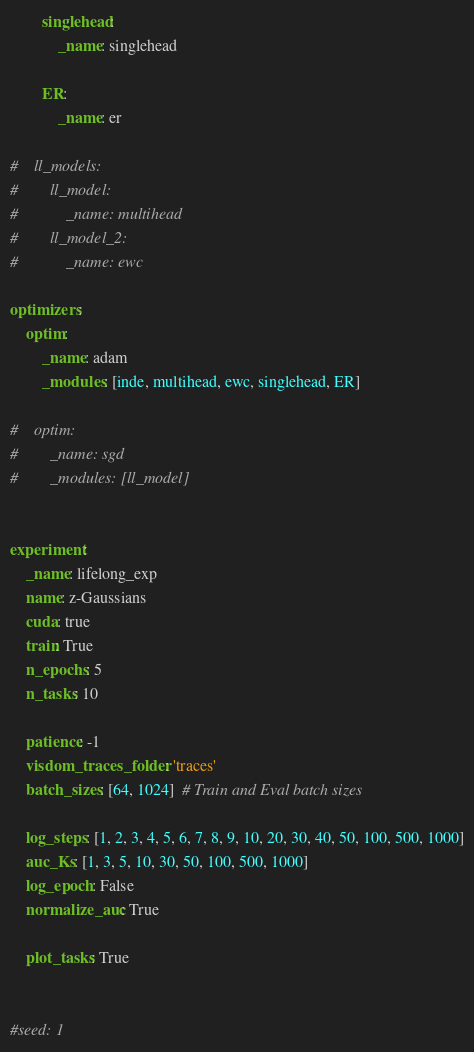Convert code to text. <code><loc_0><loc_0><loc_500><loc_500><_YAML_>        singlehead:
            _name: singlehead

        ER:
            _name: er

#    ll_models:
#        ll_model:
#            _name: multihead
#        ll_model_2:
#            _name: ewc

optimizers:
    optim:
        _name: adam
        _modules: [inde, multihead, ewc, singlehead, ER]

#    optim:
#        _name: sgd
#        _modules: [ll_model]


experiment:
    _name: lifelong_exp
    name: z-Gaussians
    cuda: true
    train: True
    n_epochs: 5
    n_tasks: 10

    patience: -1
    visdom_traces_folder: 'traces'
    batch_sizes: [64, 1024]  # Train and Eval batch sizes

    log_steps: [1, 2, 3, 4, 5, 6, 7, 8, 9, 10, 20, 30, 40, 50, 100, 500, 1000]
    auc_Ks: [1, 3, 5, 10, 30, 50, 100, 500, 1000]
    log_epoch: False
    normalize_auc: True

    plot_tasks: True


#seed: 1</code> 